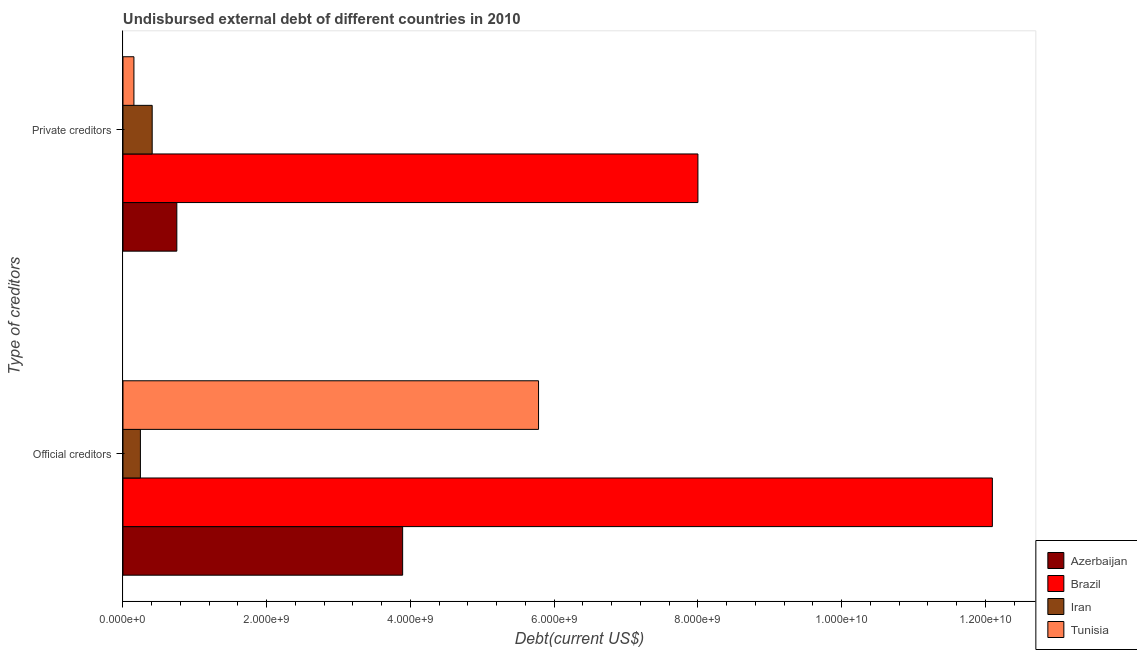How many groups of bars are there?
Your answer should be very brief. 2. Are the number of bars on each tick of the Y-axis equal?
Provide a succinct answer. Yes. How many bars are there on the 2nd tick from the bottom?
Your response must be concise. 4. What is the label of the 1st group of bars from the top?
Make the answer very short. Private creditors. What is the undisbursed external debt of private creditors in Azerbaijan?
Provide a succinct answer. 7.49e+08. Across all countries, what is the maximum undisbursed external debt of private creditors?
Provide a succinct answer. 8.00e+09. Across all countries, what is the minimum undisbursed external debt of private creditors?
Your answer should be very brief. 1.52e+08. In which country was the undisbursed external debt of private creditors maximum?
Keep it short and to the point. Brazil. In which country was the undisbursed external debt of official creditors minimum?
Your answer should be compact. Iran. What is the total undisbursed external debt of private creditors in the graph?
Keep it short and to the point. 9.31e+09. What is the difference between the undisbursed external debt of private creditors in Azerbaijan and that in Iran?
Provide a short and direct response. 3.43e+08. What is the difference between the undisbursed external debt of private creditors in Azerbaijan and the undisbursed external debt of official creditors in Brazil?
Your answer should be compact. -1.13e+1. What is the average undisbursed external debt of private creditors per country?
Provide a succinct answer. 2.33e+09. What is the difference between the undisbursed external debt of private creditors and undisbursed external debt of official creditors in Iran?
Offer a very short reply. 1.64e+08. In how many countries, is the undisbursed external debt of official creditors greater than 10800000000 US$?
Provide a succinct answer. 1. What is the ratio of the undisbursed external debt of private creditors in Brazil to that in Tunisia?
Your response must be concise. 52.52. What does the 2nd bar from the top in Private creditors represents?
Provide a succinct answer. Iran. What does the 4th bar from the bottom in Private creditors represents?
Offer a terse response. Tunisia. How many countries are there in the graph?
Offer a very short reply. 4. Are the values on the major ticks of X-axis written in scientific E-notation?
Offer a terse response. Yes. Where does the legend appear in the graph?
Provide a succinct answer. Bottom right. How are the legend labels stacked?
Your answer should be compact. Vertical. What is the title of the graph?
Keep it short and to the point. Undisbursed external debt of different countries in 2010. What is the label or title of the X-axis?
Your answer should be compact. Debt(current US$). What is the label or title of the Y-axis?
Provide a short and direct response. Type of creditors. What is the Debt(current US$) in Azerbaijan in Official creditors?
Make the answer very short. 3.89e+09. What is the Debt(current US$) in Brazil in Official creditors?
Give a very brief answer. 1.21e+1. What is the Debt(current US$) in Iran in Official creditors?
Give a very brief answer. 2.43e+08. What is the Debt(current US$) in Tunisia in Official creditors?
Provide a succinct answer. 5.78e+09. What is the Debt(current US$) in Azerbaijan in Private creditors?
Provide a short and direct response. 7.49e+08. What is the Debt(current US$) of Brazil in Private creditors?
Give a very brief answer. 8.00e+09. What is the Debt(current US$) of Iran in Private creditors?
Your response must be concise. 4.06e+08. What is the Debt(current US$) in Tunisia in Private creditors?
Keep it short and to the point. 1.52e+08. Across all Type of creditors, what is the maximum Debt(current US$) in Azerbaijan?
Provide a short and direct response. 3.89e+09. Across all Type of creditors, what is the maximum Debt(current US$) in Brazil?
Make the answer very short. 1.21e+1. Across all Type of creditors, what is the maximum Debt(current US$) of Iran?
Provide a succinct answer. 4.06e+08. Across all Type of creditors, what is the maximum Debt(current US$) of Tunisia?
Keep it short and to the point. 5.78e+09. Across all Type of creditors, what is the minimum Debt(current US$) in Azerbaijan?
Offer a very short reply. 7.49e+08. Across all Type of creditors, what is the minimum Debt(current US$) of Brazil?
Offer a very short reply. 8.00e+09. Across all Type of creditors, what is the minimum Debt(current US$) in Iran?
Your answer should be very brief. 2.43e+08. Across all Type of creditors, what is the minimum Debt(current US$) in Tunisia?
Provide a succinct answer. 1.52e+08. What is the total Debt(current US$) in Azerbaijan in the graph?
Your answer should be very brief. 4.64e+09. What is the total Debt(current US$) of Brazil in the graph?
Your answer should be compact. 2.01e+1. What is the total Debt(current US$) of Iran in the graph?
Keep it short and to the point. 6.49e+08. What is the total Debt(current US$) of Tunisia in the graph?
Make the answer very short. 5.94e+09. What is the difference between the Debt(current US$) of Azerbaijan in Official creditors and that in Private creditors?
Provide a short and direct response. 3.14e+09. What is the difference between the Debt(current US$) of Brazil in Official creditors and that in Private creditors?
Provide a succinct answer. 4.10e+09. What is the difference between the Debt(current US$) in Iran in Official creditors and that in Private creditors?
Offer a very short reply. -1.64e+08. What is the difference between the Debt(current US$) of Tunisia in Official creditors and that in Private creditors?
Your answer should be compact. 5.63e+09. What is the difference between the Debt(current US$) in Azerbaijan in Official creditors and the Debt(current US$) in Brazil in Private creditors?
Provide a short and direct response. -4.11e+09. What is the difference between the Debt(current US$) of Azerbaijan in Official creditors and the Debt(current US$) of Iran in Private creditors?
Keep it short and to the point. 3.49e+09. What is the difference between the Debt(current US$) of Azerbaijan in Official creditors and the Debt(current US$) of Tunisia in Private creditors?
Your response must be concise. 3.74e+09. What is the difference between the Debt(current US$) in Brazil in Official creditors and the Debt(current US$) in Iran in Private creditors?
Keep it short and to the point. 1.17e+1. What is the difference between the Debt(current US$) in Brazil in Official creditors and the Debt(current US$) in Tunisia in Private creditors?
Your answer should be compact. 1.19e+1. What is the difference between the Debt(current US$) of Iran in Official creditors and the Debt(current US$) of Tunisia in Private creditors?
Offer a terse response. 9.02e+07. What is the average Debt(current US$) of Azerbaijan per Type of creditors?
Your answer should be compact. 2.32e+09. What is the average Debt(current US$) in Brazil per Type of creditors?
Keep it short and to the point. 1.01e+1. What is the average Debt(current US$) of Iran per Type of creditors?
Ensure brevity in your answer.  3.24e+08. What is the average Debt(current US$) in Tunisia per Type of creditors?
Keep it short and to the point. 2.97e+09. What is the difference between the Debt(current US$) in Azerbaijan and Debt(current US$) in Brazil in Official creditors?
Make the answer very short. -8.21e+09. What is the difference between the Debt(current US$) of Azerbaijan and Debt(current US$) of Iran in Official creditors?
Provide a short and direct response. 3.65e+09. What is the difference between the Debt(current US$) of Azerbaijan and Debt(current US$) of Tunisia in Official creditors?
Your response must be concise. -1.89e+09. What is the difference between the Debt(current US$) of Brazil and Debt(current US$) of Iran in Official creditors?
Give a very brief answer. 1.19e+1. What is the difference between the Debt(current US$) of Brazil and Debt(current US$) of Tunisia in Official creditors?
Your response must be concise. 6.32e+09. What is the difference between the Debt(current US$) of Iran and Debt(current US$) of Tunisia in Official creditors?
Ensure brevity in your answer.  -5.54e+09. What is the difference between the Debt(current US$) in Azerbaijan and Debt(current US$) in Brazil in Private creditors?
Ensure brevity in your answer.  -7.25e+09. What is the difference between the Debt(current US$) of Azerbaijan and Debt(current US$) of Iran in Private creditors?
Ensure brevity in your answer.  3.43e+08. What is the difference between the Debt(current US$) in Azerbaijan and Debt(current US$) in Tunisia in Private creditors?
Make the answer very short. 5.97e+08. What is the difference between the Debt(current US$) of Brazil and Debt(current US$) of Iran in Private creditors?
Provide a succinct answer. 7.59e+09. What is the difference between the Debt(current US$) of Brazil and Debt(current US$) of Tunisia in Private creditors?
Provide a succinct answer. 7.85e+09. What is the difference between the Debt(current US$) in Iran and Debt(current US$) in Tunisia in Private creditors?
Your answer should be very brief. 2.54e+08. What is the ratio of the Debt(current US$) in Azerbaijan in Official creditors to that in Private creditors?
Your response must be concise. 5.19. What is the ratio of the Debt(current US$) of Brazil in Official creditors to that in Private creditors?
Offer a terse response. 1.51. What is the ratio of the Debt(current US$) of Iran in Official creditors to that in Private creditors?
Your response must be concise. 0.6. What is the ratio of the Debt(current US$) of Tunisia in Official creditors to that in Private creditors?
Provide a succinct answer. 37.96. What is the difference between the highest and the second highest Debt(current US$) in Azerbaijan?
Give a very brief answer. 3.14e+09. What is the difference between the highest and the second highest Debt(current US$) of Brazil?
Your answer should be compact. 4.10e+09. What is the difference between the highest and the second highest Debt(current US$) of Iran?
Provide a succinct answer. 1.64e+08. What is the difference between the highest and the second highest Debt(current US$) in Tunisia?
Make the answer very short. 5.63e+09. What is the difference between the highest and the lowest Debt(current US$) of Azerbaijan?
Provide a succinct answer. 3.14e+09. What is the difference between the highest and the lowest Debt(current US$) of Brazil?
Your response must be concise. 4.10e+09. What is the difference between the highest and the lowest Debt(current US$) in Iran?
Ensure brevity in your answer.  1.64e+08. What is the difference between the highest and the lowest Debt(current US$) in Tunisia?
Your response must be concise. 5.63e+09. 